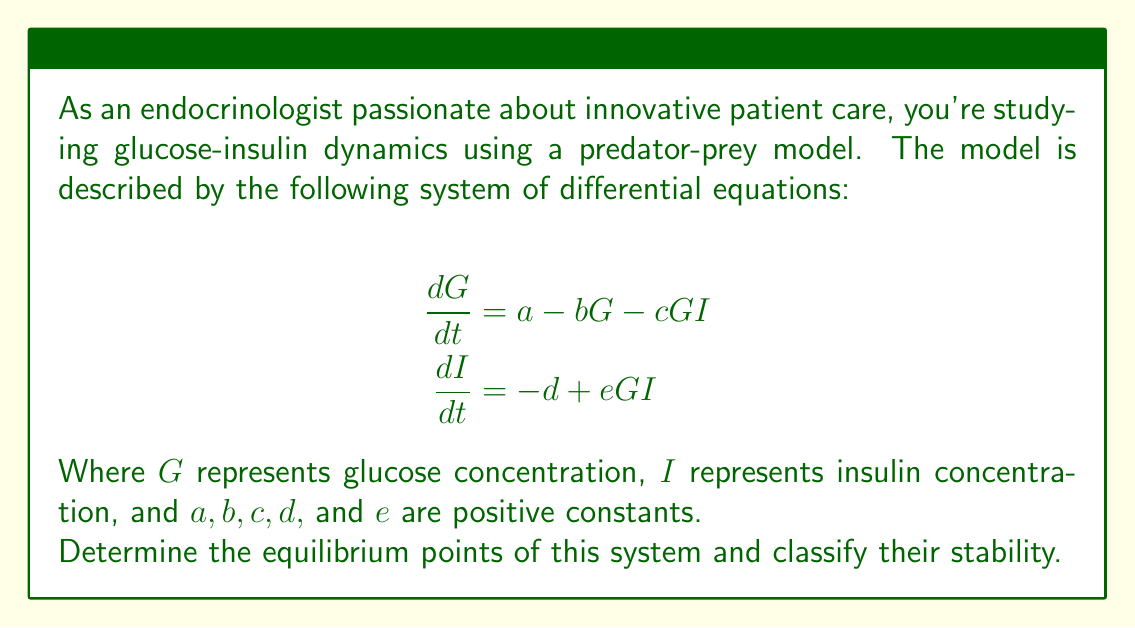Help me with this question. To solve this problem, we'll follow these steps:

1) Find the equilibrium points by setting both derivatives to zero.
2) Analyze the stability of each equilibrium point using the Jacobian matrix.

Step 1: Finding equilibrium points

Set both derivatives to zero:

$$\begin{align}
0 &= a - bG - cGI \\
0 &= -d + eGI
\end{align}$$

From the second equation:
$eGI = d$
$I = \frac{d}{eG}$

Substituting this into the first equation:

$$\begin{align}
0 &= a - bG - cG(\frac{d}{eG}) \\
0 &= a - bG - \frac{cd}{e} \\
bG &= a - \frac{cd}{e} \\
G &= \frac{ae - cd}{be}
\end{align}$$

Therefore, the equilibrium point is:

$$(G^*, I^*) = \left(\frac{ae - cd}{be}, \frac{bde}{ae - cd}\right)$$

Note that this equilibrium point exists only when $ae > cd$.

Step 2: Stability analysis

To analyze stability, we need to find the Jacobian matrix:

$$J = \begin{bmatrix}
\frac{\partial}{\partial G}(a - bG - cGI) & \frac{\partial}{\partial I}(a - bG - cGI) \\
\frac{\partial}{\partial G}(-d + eGI) & \frac{\partial}{\partial I}(-d + eGI)
\end{bmatrix}$$

$$J = \begin{bmatrix}
-b - cI & -cG \\
eI & eG
\end{bmatrix}$$

Evaluating at the equilibrium point:

$$J^* = \begin{bmatrix}
-b - c\frac{bde}{ae - cd} & -c\frac{ae - cd}{be} \\
e\frac{bde}{ae - cd} & e\frac{ae - cd}{be}
\end{bmatrix}$$

The stability of the equilibrium point depends on the eigenvalues of this Jacobian matrix. If both eigenvalues have negative real parts, the equilibrium point is stable. If at least one eigenvalue has a positive real part, the equilibrium point is unstable.

The characteristic equation is:

$$\det(J^* - \lambda I) = \lambda^2 + \left(b + c\frac{bde}{ae - cd} - e\frac{ae - cd}{be}\right)\lambda + \frac{cd}{e} - a = 0$$

The equilibrium point is stable if and only if:

1) $b + c\frac{bde}{ae - cd} - e\frac{ae - cd}{be} > 0$
2) $\frac{cd}{e} - a > 0$

These conditions depend on the specific values of the parameters $a, b, c, d,$ and $e$.
Answer: The system has one equilibrium point: $$(G^*, I^*) = \left(\frac{ae - cd}{be}, \frac{bde}{ae - cd}\right)$$

This equilibrium point exists when $ae > cd$. Its stability depends on the specific values of the parameters $a, b, c, d,$ and $e$, and can be determined by analyzing the eigenvalues of the Jacobian matrix evaluated at this point. 